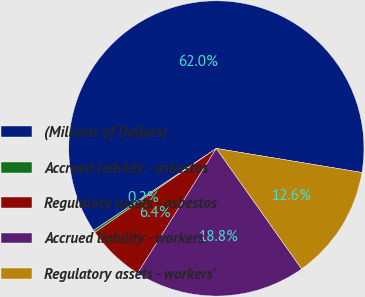<chart> <loc_0><loc_0><loc_500><loc_500><pie_chart><fcel>(Millions of Dollars)<fcel>Accrued liability - asbestos<fcel>Regulatory assets - asbestos<fcel>Accrued liability - workers'<fcel>Regulatory assets - workers'<nl><fcel>61.98%<fcel>0.25%<fcel>6.42%<fcel>18.77%<fcel>12.59%<nl></chart> 